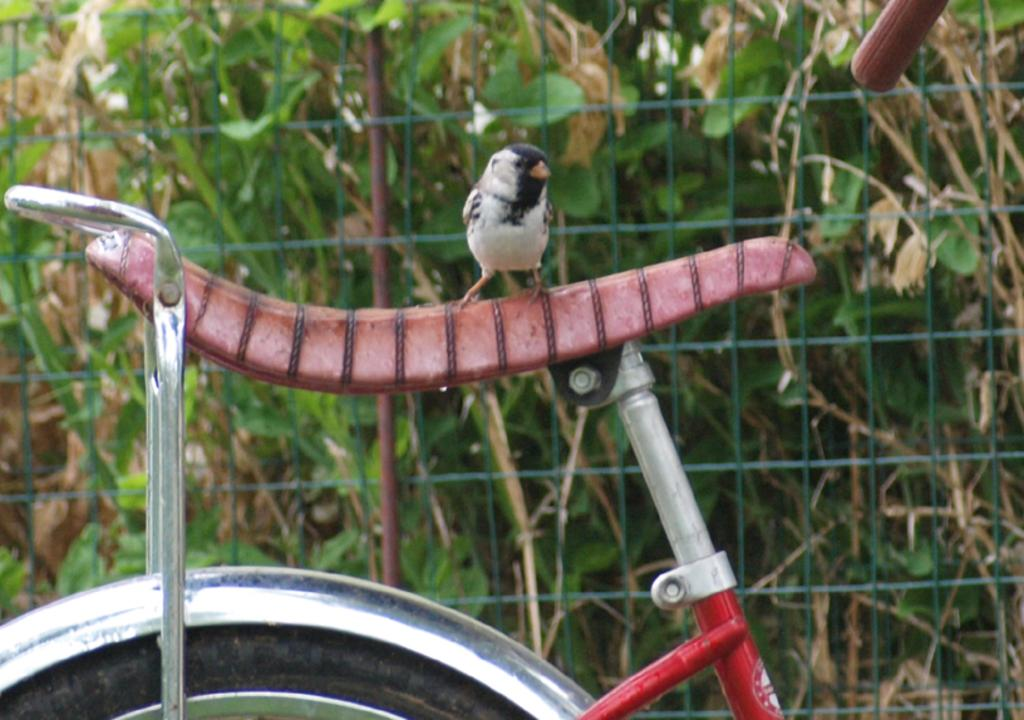What is the main object in the image? There is a cycle in the image. What is on the cycle? A bird is standing on the seat of the cycle. What can be seen in the background of the image? There is a mesh in the background of the image. What type of vegetation is visible behind the mesh? Plants are visible behind the mesh. What type of toys can be seen in the image? There are no toys present in the image. What kind of trouble is the bird causing on the cycle? The bird is not causing any trouble on the cycle; it is simply standing on the seat. 